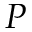<formula> <loc_0><loc_0><loc_500><loc_500>P</formula> 